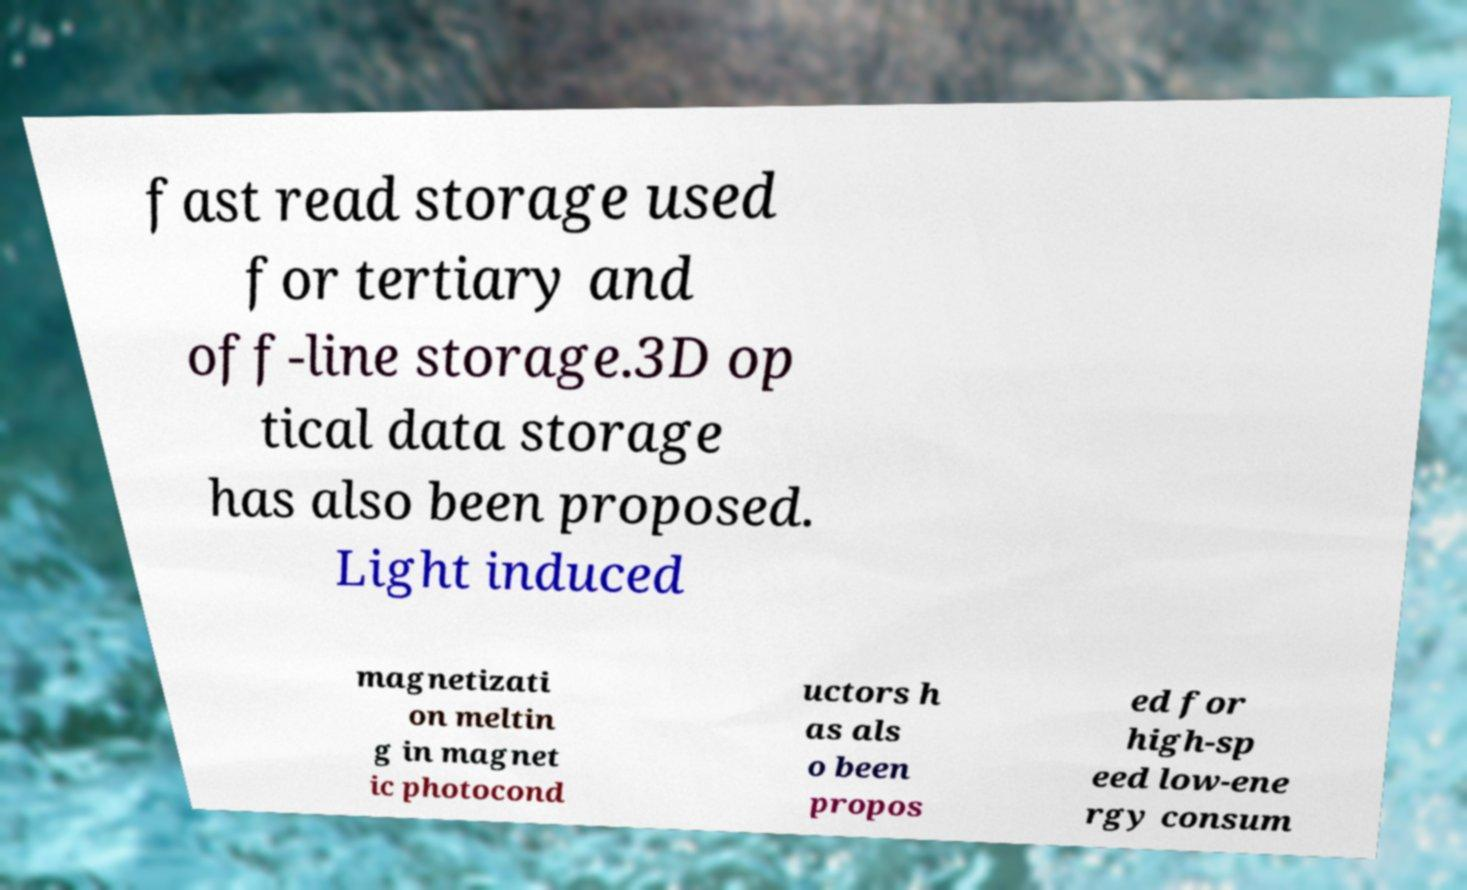There's text embedded in this image that I need extracted. Can you transcribe it verbatim? fast read storage used for tertiary and off-line storage.3D op tical data storage has also been proposed. Light induced magnetizati on meltin g in magnet ic photocond uctors h as als o been propos ed for high-sp eed low-ene rgy consum 